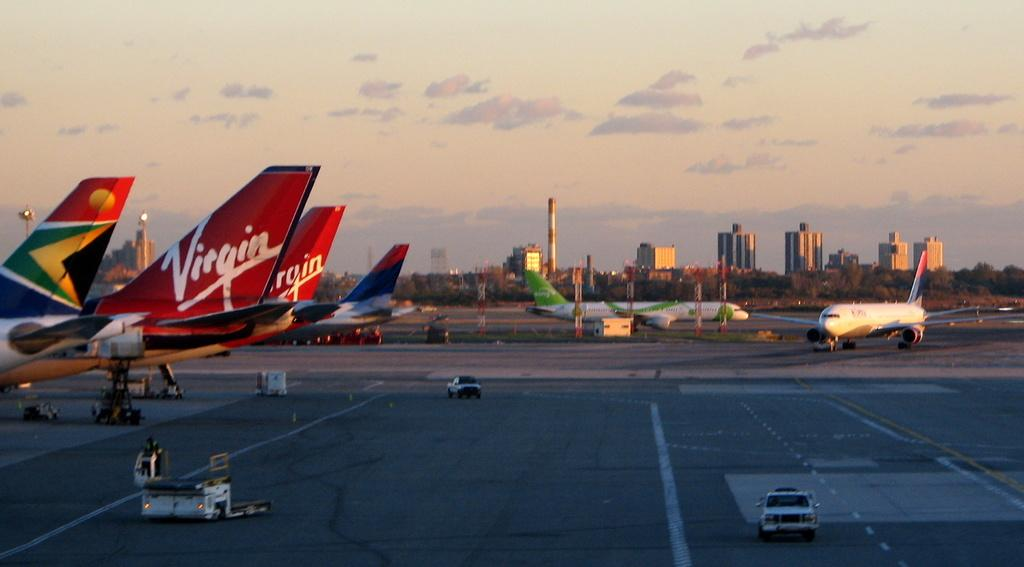Provide a one-sentence caption for the provided image. Two Virgin Airlines planes sit on the tarmac. 